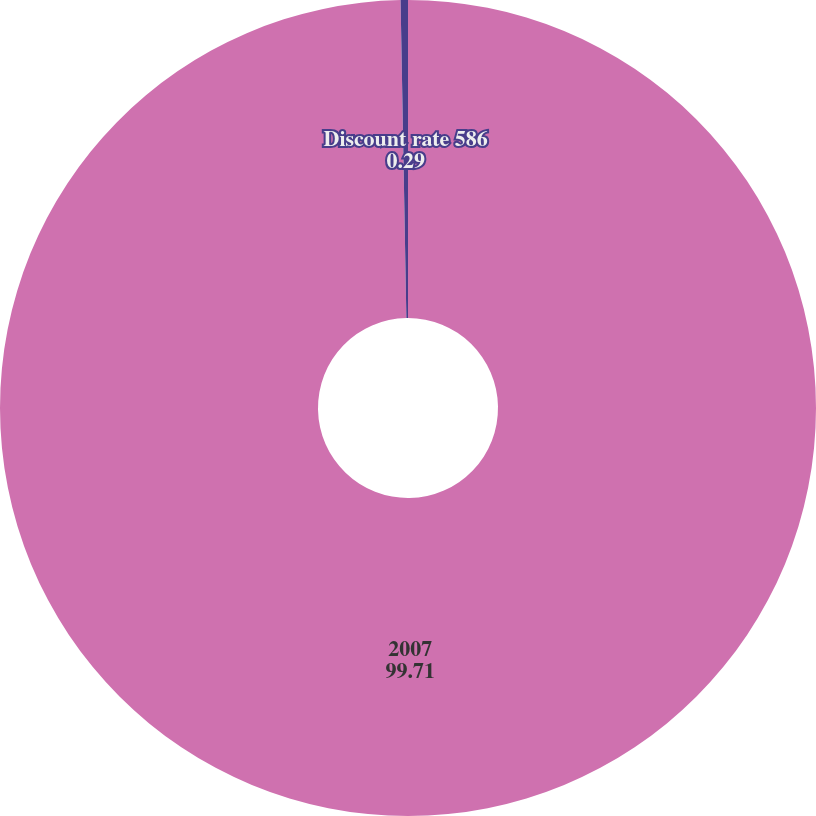<chart> <loc_0><loc_0><loc_500><loc_500><pie_chart><fcel>2007<fcel>Discount rate 586<nl><fcel>99.71%<fcel>0.29%<nl></chart> 